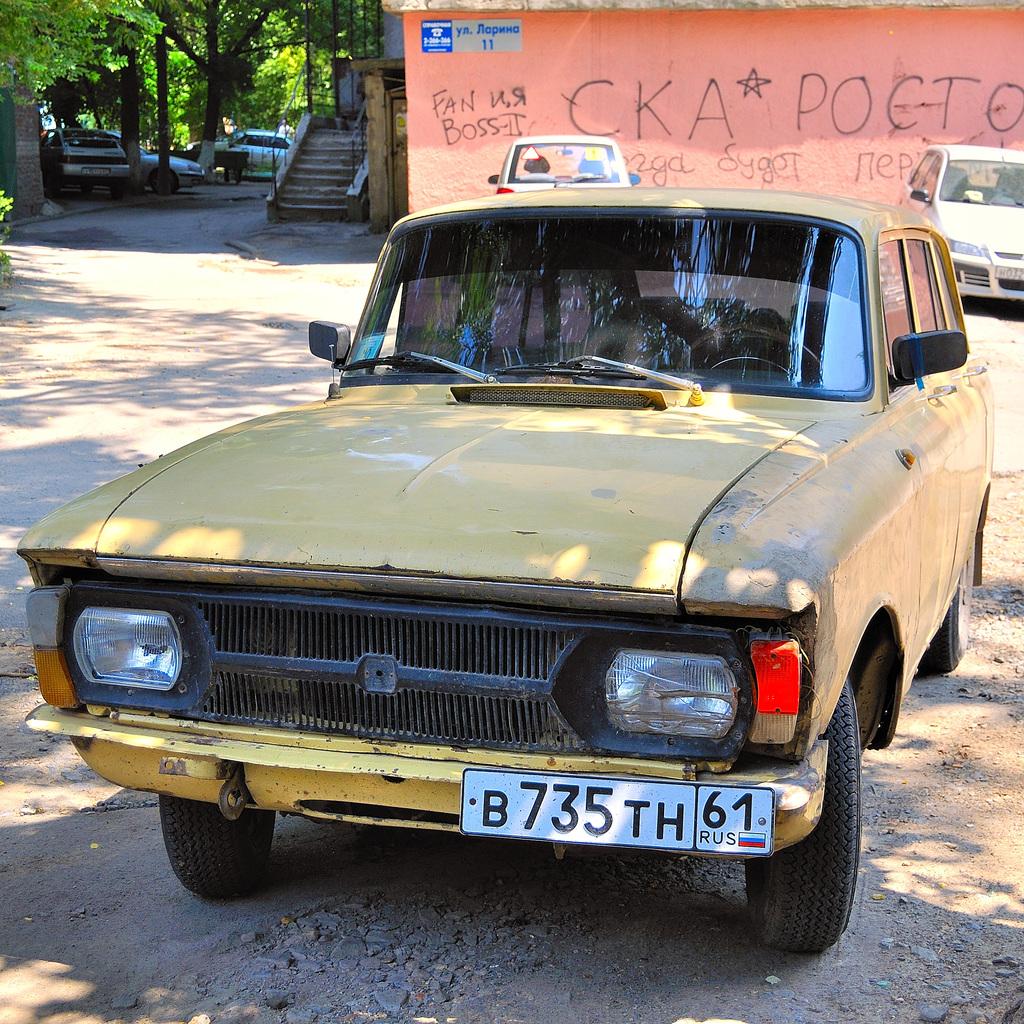Is that a car plate ?
Offer a very short reply. Yes. What is the license plate number?
Provide a succinct answer. B735th61. 